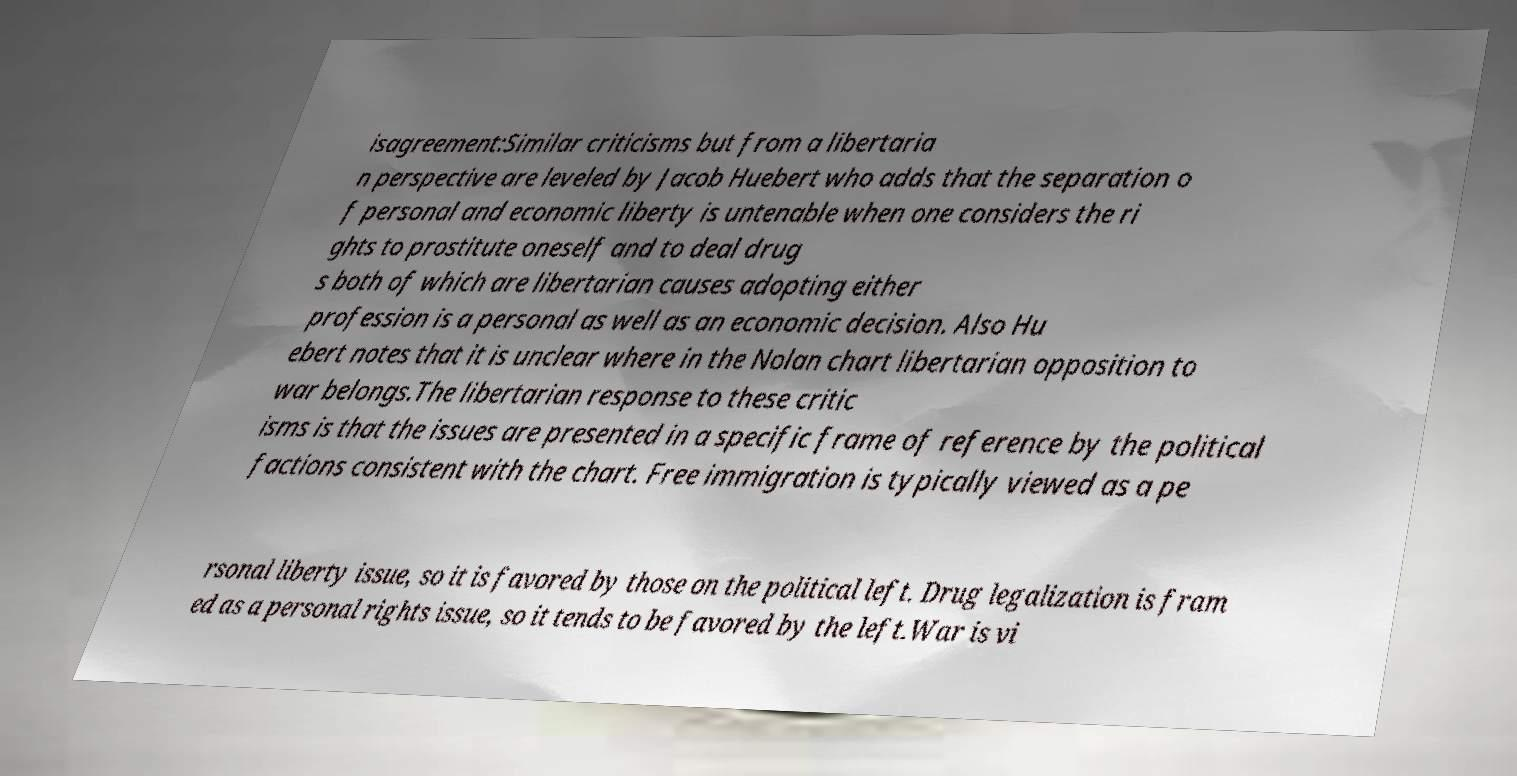Please identify and transcribe the text found in this image. isagreement:Similar criticisms but from a libertaria n perspective are leveled by Jacob Huebert who adds that the separation o f personal and economic liberty is untenable when one considers the ri ghts to prostitute oneself and to deal drug s both of which are libertarian causes adopting either profession is a personal as well as an economic decision. Also Hu ebert notes that it is unclear where in the Nolan chart libertarian opposition to war belongs.The libertarian response to these critic isms is that the issues are presented in a specific frame of reference by the political factions consistent with the chart. Free immigration is typically viewed as a pe rsonal liberty issue, so it is favored by those on the political left. Drug legalization is fram ed as a personal rights issue, so it tends to be favored by the left.War is vi 